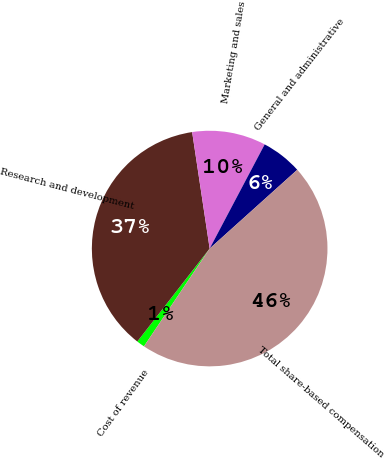Convert chart to OTSL. <chart><loc_0><loc_0><loc_500><loc_500><pie_chart><fcel>Cost of revenue<fcel>Research and development<fcel>Marketing and sales<fcel>General and administrative<fcel>Total share-based compensation<nl><fcel>1.11%<fcel>37.1%<fcel>10.11%<fcel>5.61%<fcel>46.07%<nl></chart> 